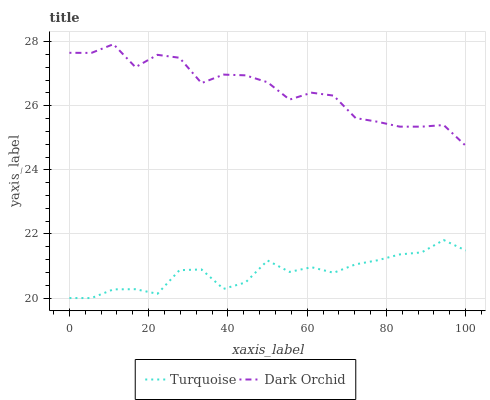Does Turquoise have the minimum area under the curve?
Answer yes or no. Yes. Does Dark Orchid have the maximum area under the curve?
Answer yes or no. Yes. Does Dark Orchid have the minimum area under the curve?
Answer yes or no. No. Is Turquoise the smoothest?
Answer yes or no. Yes. Is Dark Orchid the roughest?
Answer yes or no. Yes. Is Dark Orchid the smoothest?
Answer yes or no. No. Does Turquoise have the lowest value?
Answer yes or no. Yes. Does Dark Orchid have the lowest value?
Answer yes or no. No. Does Dark Orchid have the highest value?
Answer yes or no. Yes. Is Turquoise less than Dark Orchid?
Answer yes or no. Yes. Is Dark Orchid greater than Turquoise?
Answer yes or no. Yes. Does Turquoise intersect Dark Orchid?
Answer yes or no. No. 